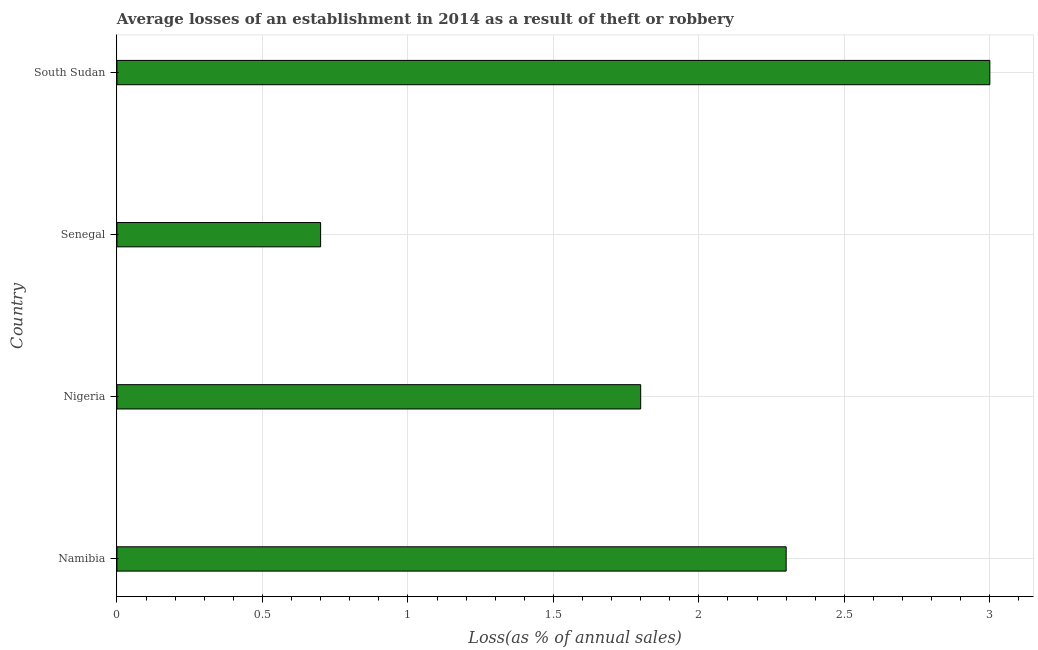Does the graph contain grids?
Your response must be concise. Yes. What is the title of the graph?
Make the answer very short. Average losses of an establishment in 2014 as a result of theft or robbery. What is the label or title of the X-axis?
Provide a succinct answer. Loss(as % of annual sales). What is the losses due to theft in Nigeria?
Your answer should be very brief. 1.8. Across all countries, what is the minimum losses due to theft?
Ensure brevity in your answer.  0.7. In which country was the losses due to theft maximum?
Your response must be concise. South Sudan. In which country was the losses due to theft minimum?
Provide a succinct answer. Senegal. What is the sum of the losses due to theft?
Ensure brevity in your answer.  7.8. What is the difference between the losses due to theft in Senegal and South Sudan?
Your answer should be compact. -2.3. What is the average losses due to theft per country?
Your response must be concise. 1.95. What is the median losses due to theft?
Provide a succinct answer. 2.05. What is the ratio of the losses due to theft in Namibia to that in Nigeria?
Your response must be concise. 1.28. Is the difference between the losses due to theft in Nigeria and Senegal greater than the difference between any two countries?
Provide a succinct answer. No. Is the sum of the losses due to theft in Namibia and Senegal greater than the maximum losses due to theft across all countries?
Offer a very short reply. No. What is the difference between the highest and the lowest losses due to theft?
Provide a short and direct response. 2.3. In how many countries, is the losses due to theft greater than the average losses due to theft taken over all countries?
Offer a terse response. 2. How many countries are there in the graph?
Ensure brevity in your answer.  4. What is the difference between two consecutive major ticks on the X-axis?
Give a very brief answer. 0.5. Are the values on the major ticks of X-axis written in scientific E-notation?
Your answer should be compact. No. What is the Loss(as % of annual sales) of Namibia?
Your answer should be very brief. 2.3. What is the Loss(as % of annual sales) of Senegal?
Provide a short and direct response. 0.7. What is the Loss(as % of annual sales) in South Sudan?
Give a very brief answer. 3. What is the difference between the Loss(as % of annual sales) in Namibia and Nigeria?
Offer a very short reply. 0.5. What is the difference between the Loss(as % of annual sales) in Nigeria and Senegal?
Provide a succinct answer. 1.1. What is the difference between the Loss(as % of annual sales) in Nigeria and South Sudan?
Ensure brevity in your answer.  -1.2. What is the difference between the Loss(as % of annual sales) in Senegal and South Sudan?
Ensure brevity in your answer.  -2.3. What is the ratio of the Loss(as % of annual sales) in Namibia to that in Nigeria?
Your answer should be very brief. 1.28. What is the ratio of the Loss(as % of annual sales) in Namibia to that in Senegal?
Your response must be concise. 3.29. What is the ratio of the Loss(as % of annual sales) in Namibia to that in South Sudan?
Offer a terse response. 0.77. What is the ratio of the Loss(as % of annual sales) in Nigeria to that in Senegal?
Keep it short and to the point. 2.57. What is the ratio of the Loss(as % of annual sales) in Senegal to that in South Sudan?
Ensure brevity in your answer.  0.23. 